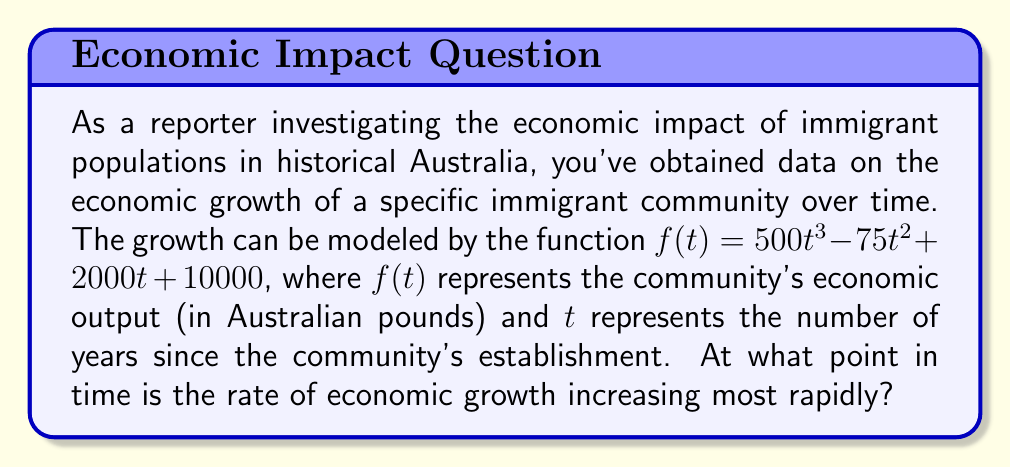Can you answer this question? To solve this problem, we need to analyze the rate of change of the growth rate. This involves finding the second derivative of the function and determining where it reaches its maximum value.

1. First, let's find the first derivative of $f(t)$, which represents the rate of economic growth:
   $$f'(t) = 1500t^2 - 150t + 2000$$

2. Now, we need to find the second derivative, which represents the rate of change of the growth rate:
   $$f''(t) = 3000t - 150$$

3. To find the point where the rate of growth is increasing most rapidly, we need to find the maximum value of $f''(t)$. Since $f''(t)$ is a linear function, its maximum (or minimum) will occur at the endpoints of the domain or where its derivative equals zero.

4. Let's find where $f''(t) = 0$:
   $$3000t - 150 = 0$$
   $$3000t = 150$$
   $$t = \frac{150}{3000} = 0.05$$

5. Since this is a linear function and we found a critical point, this must be the point where the rate of growth is increasing most rapidly.

6. To confirm, we can check the sign of $f'''(t)$:
   $$f'''(t) = 3000$$
   Since this is positive, we know that $f''(t)$ is always increasing, so our critical point is indeed a minimum.

Therefore, the rate of economic growth is increasing most rapidly at $t = 0.05$ years, or approximately 18 days after the community's establishment.
Answer: The rate of economic growth is increasing most rapidly at $t = 0.05$ years (approximately 18 days) after the immigrant community's establishment. 